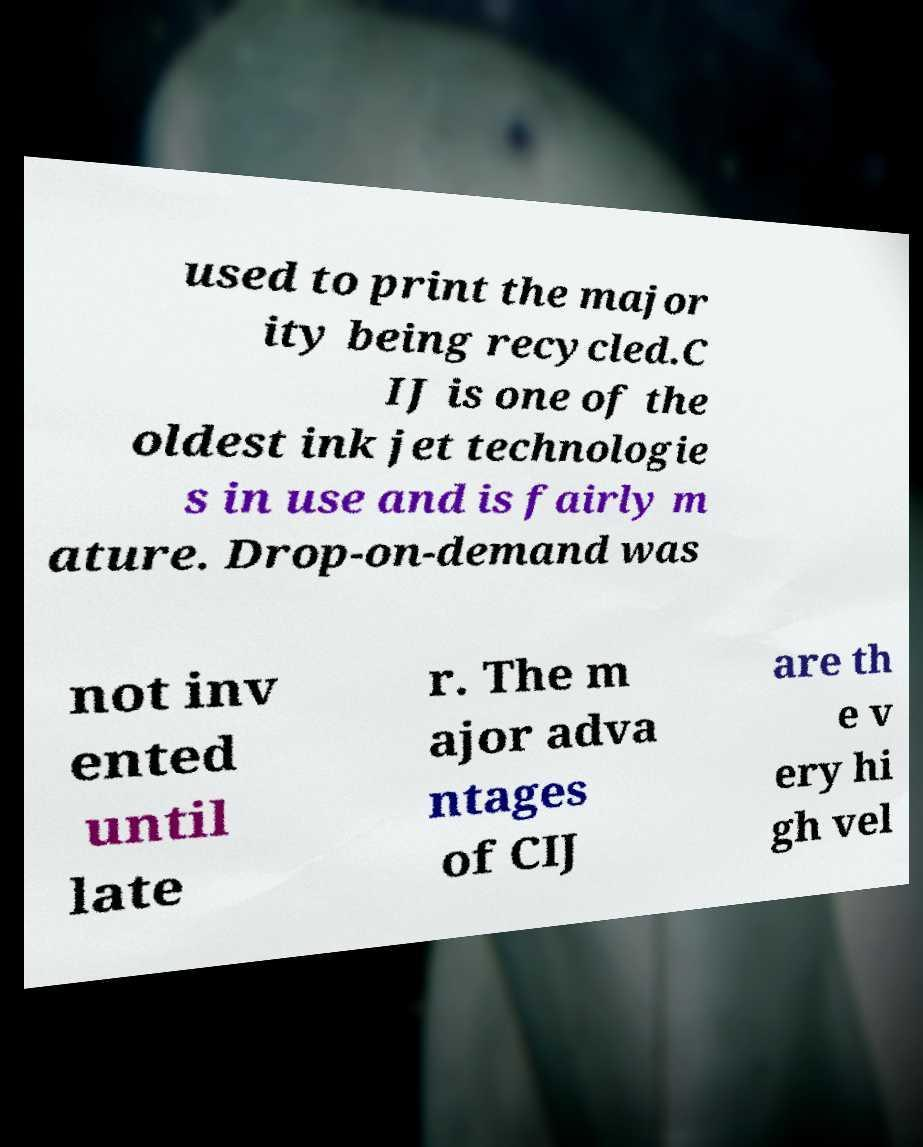Please read and relay the text visible in this image. What does it say? used to print the major ity being recycled.C IJ is one of the oldest ink jet technologie s in use and is fairly m ature. Drop-on-demand was not inv ented until late r. The m ajor adva ntages of CIJ are th e v ery hi gh vel 